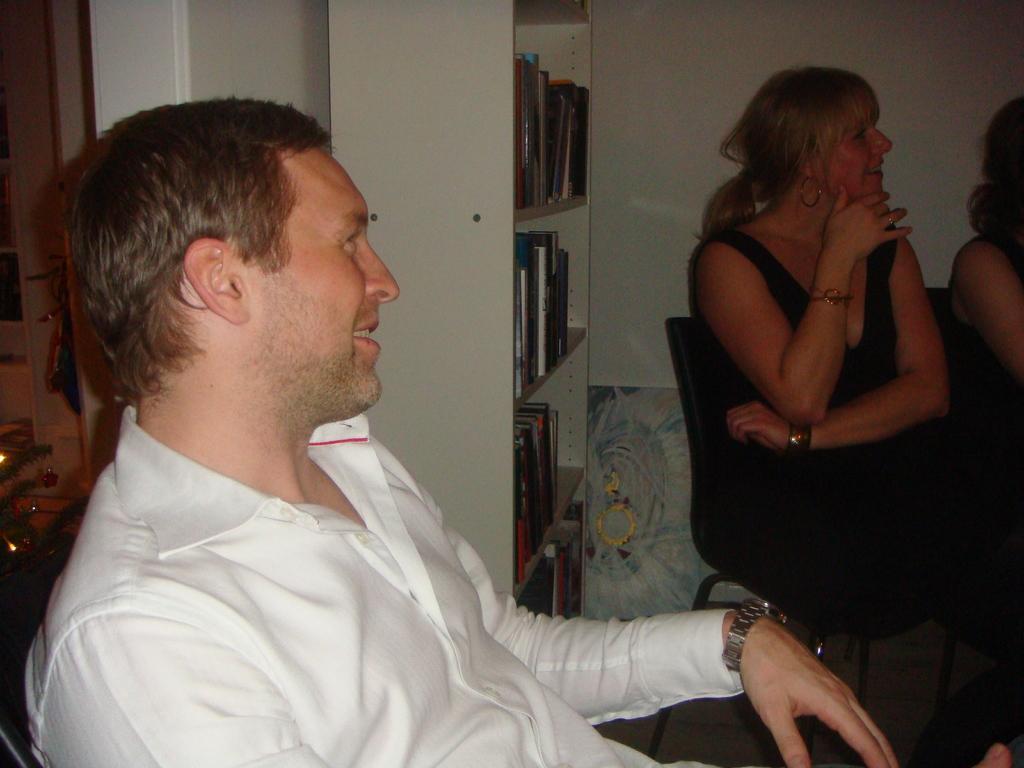Can you describe this image briefly? This picture seems to be clicked inside the room. In the foreground we can see a man wearing a shirt, smiling and sitting on the chair. On the right we can see the two people sitting on the chairs. On the left there is a cabinet containing books and some other items. In the background we can see the wall and some other objects. 